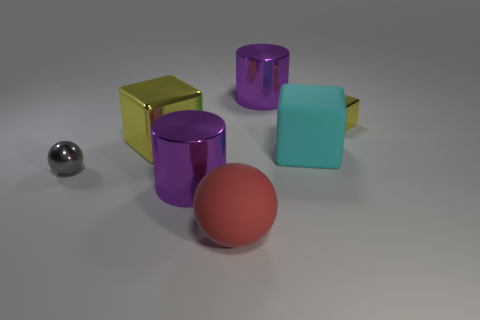Are the tiny ball and the cylinder that is on the right side of the red matte thing made of the same material?
Keep it short and to the point. Yes. There is a sphere on the right side of the large yellow block; what color is it?
Offer a very short reply. Red. Is there a big purple cylinder that is in front of the yellow block that is in front of the small yellow block?
Your response must be concise. Yes. Do the large shiny cylinder in front of the cyan block and the cylinder that is behind the gray metallic object have the same color?
Keep it short and to the point. Yes. How many metallic things are on the left side of the cyan rubber block?
Your response must be concise. 4. What number of big things are the same color as the tiny cube?
Make the answer very short. 1. Does the sphere that is behind the big red sphere have the same material as the tiny yellow block?
Keep it short and to the point. Yes. How many cylinders have the same material as the tiny ball?
Keep it short and to the point. 2. Is the number of red matte things that are left of the large shiny block greater than the number of blue shiny blocks?
Make the answer very short. No. There is a thing that is the same color as the small block; what size is it?
Make the answer very short. Large. 